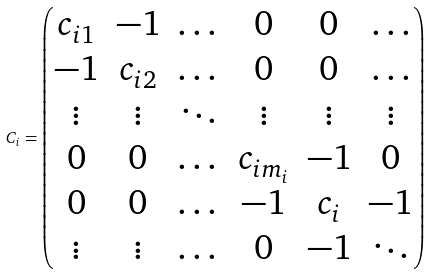Convert formula to latex. <formula><loc_0><loc_0><loc_500><loc_500>C _ { i } = \begin{pmatrix} c _ { i 1 } & - 1 & \dots & 0 & 0 & \dots \\ - 1 & c _ { i 2 } & \dots & 0 & 0 & \dots \\ \vdots & \vdots & \ddots & \vdots & \vdots & \vdots \\ 0 & 0 & \dots & c _ { i m _ { i } } & - 1 & 0 \\ 0 & 0 & \dots & - 1 & c _ { i } & - 1 \\ \vdots & \vdots & \dots & 0 & - 1 & \ddots \end{pmatrix}</formula> 